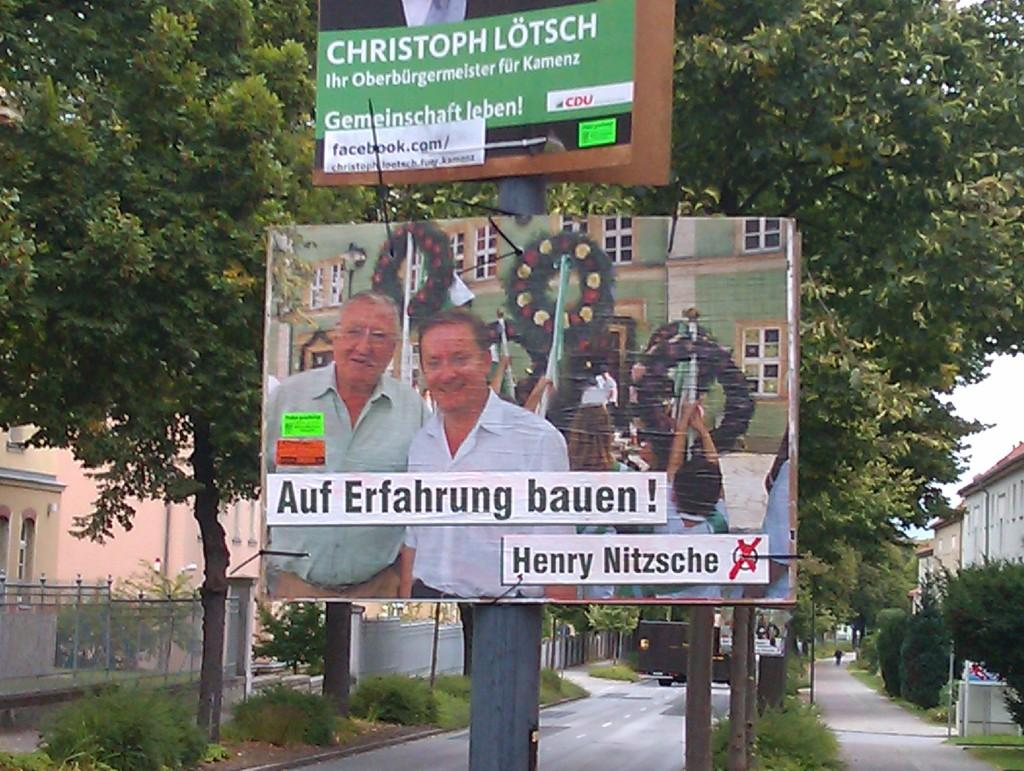<image>
Give a short and clear explanation of the subsequent image. A large poster for Christoph Lotsch sits on a pole in front of trees. 